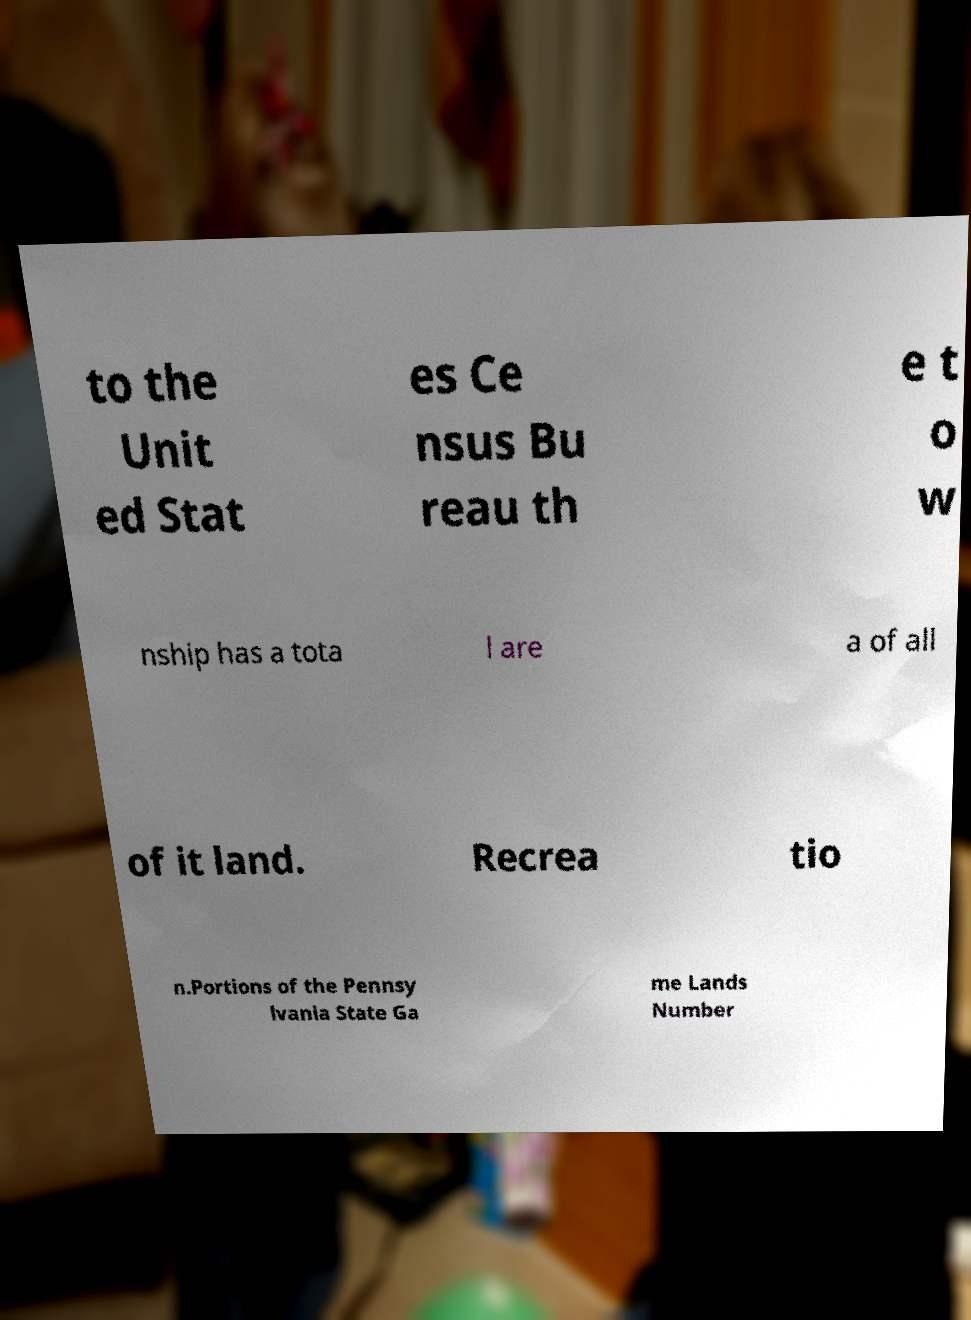What messages or text are displayed in this image? I need them in a readable, typed format. to the Unit ed Stat es Ce nsus Bu reau th e t o w nship has a tota l are a of all of it land. Recrea tio n.Portions of the Pennsy lvania State Ga me Lands Number 